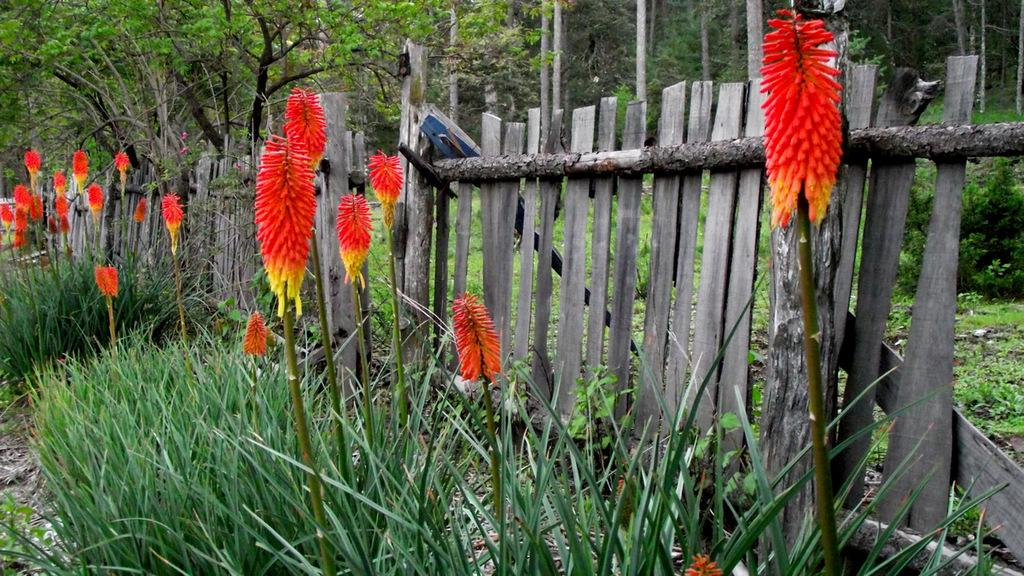What type of vegetation can be seen in the image? There are trees, flowers, and bushes in the image. What is the ground covered with in the image? There is grass on the ground in the image. What type of barrier is present in the image? There is a wooden fence in the image. How much has the growth of the flowers increased since the last time the image was taken? There is no information provided about the previous state of the flowers or the time between image captures, so it is impossible to determine any increase in growth. 